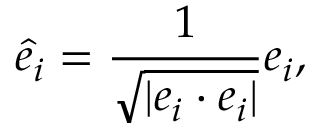Convert formula to latex. <formula><loc_0><loc_0><loc_500><loc_500>{ \hat { e } } _ { i } = { \frac { 1 } { \sqrt { | e _ { i } \cdot e _ { i } | } } } e _ { i } ,</formula> 